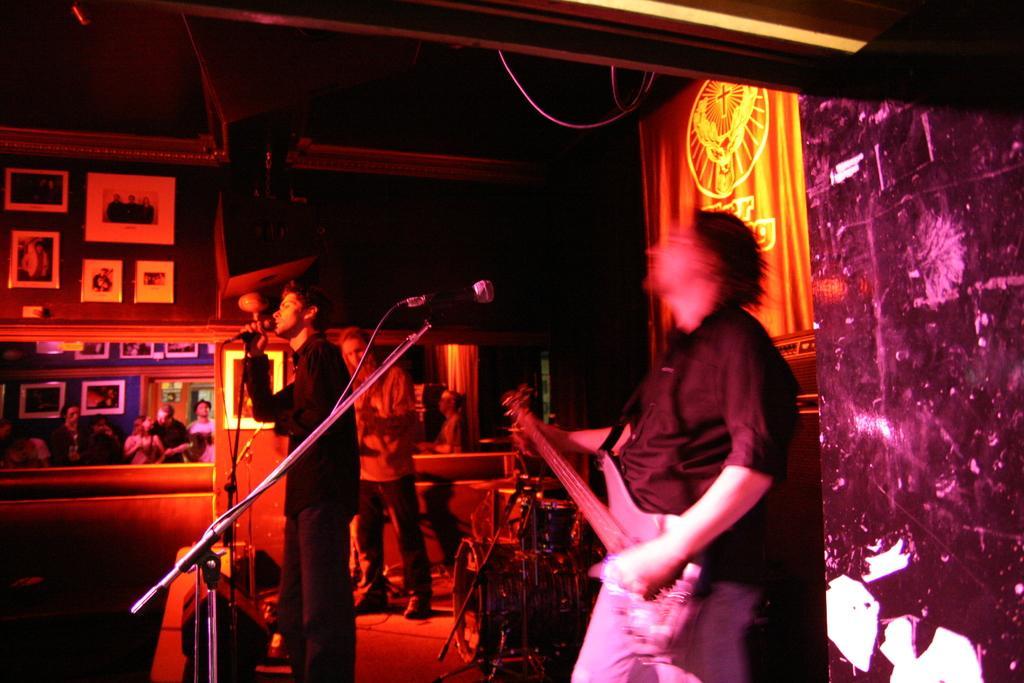How would you summarize this image in a sentence or two? In this image I see 3 persons, in which 2 of them are holding the musical instruments and this man is holding the mic. I can also see few people over here. 